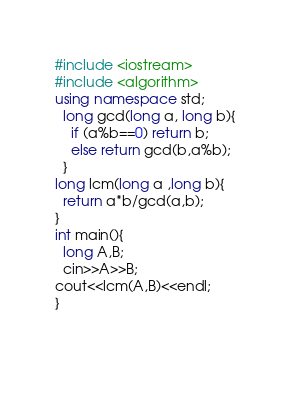<code> <loc_0><loc_0><loc_500><loc_500><_C++_>#include <iostream>
#include <algorithm>
using namespace std;
  long gcd(long a, long b){
    if (a%b==0) return b;
    else return gcd(b,a%b);
  }
long lcm(long a ,long b){
  return a*b/gcd(a,b);
}
int main(){
  long A,B;
  cin>>A>>B;
cout<<lcm(A,B)<<endl;
}
  
    
    
</code> 